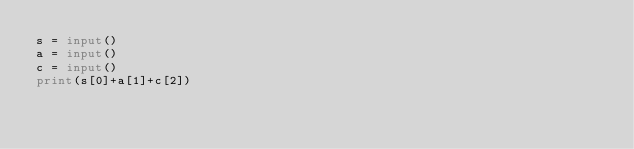Convert code to text. <code><loc_0><loc_0><loc_500><loc_500><_Python_>s = input()
a = input()
c = input()
print(s[0]+a[1]+c[2])</code> 